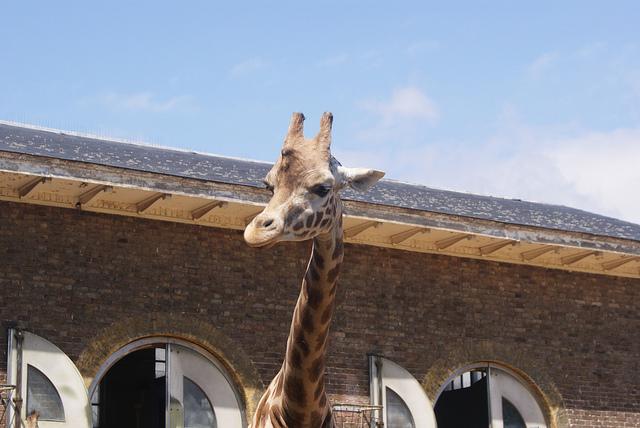What type of animal is it?
Give a very brief answer. Giraffe. Does this animal appear to be tall?
Concise answer only. Yes. Is it raining?
Keep it brief. No. 